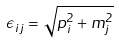Convert formula to latex. <formula><loc_0><loc_0><loc_500><loc_500>\epsilon _ { i j } = \sqrt { { p } ^ { 2 } _ { i } + m _ { j } ^ { 2 } }</formula> 